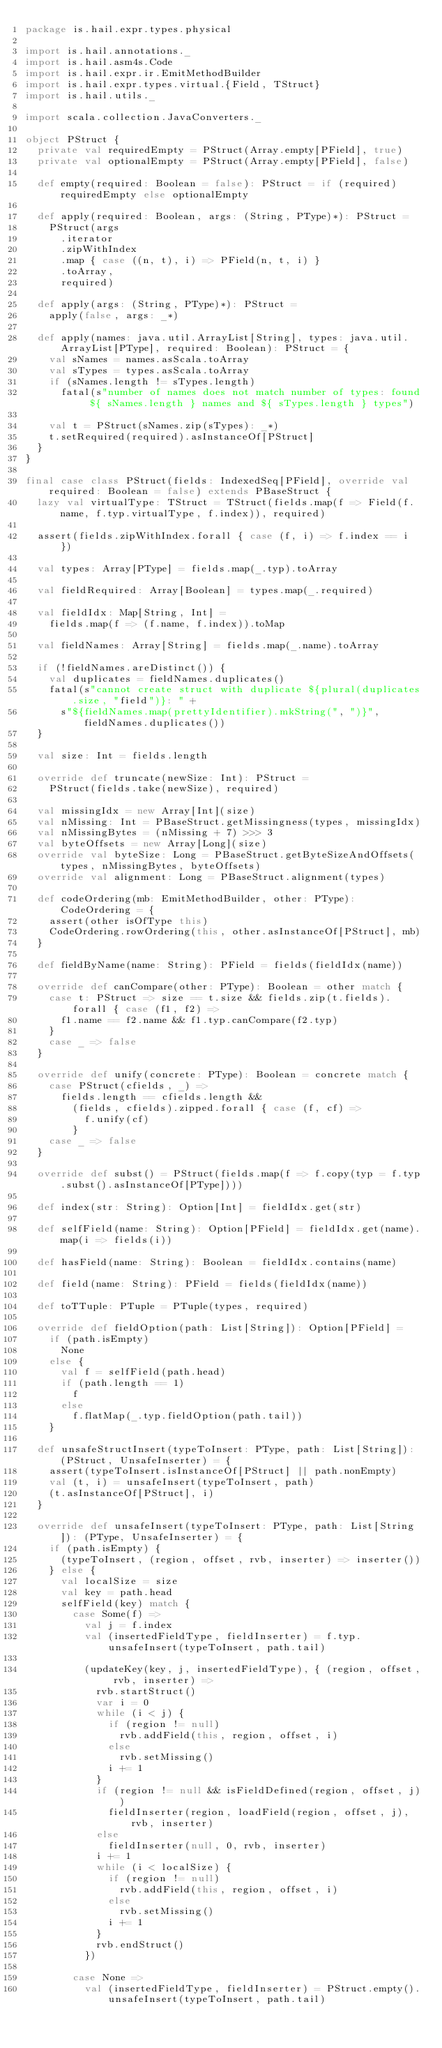<code> <loc_0><loc_0><loc_500><loc_500><_Scala_>package is.hail.expr.types.physical

import is.hail.annotations._
import is.hail.asm4s.Code
import is.hail.expr.ir.EmitMethodBuilder
import is.hail.expr.types.virtual.{Field, TStruct}
import is.hail.utils._

import scala.collection.JavaConverters._

object PStruct {
  private val requiredEmpty = PStruct(Array.empty[PField], true)
  private val optionalEmpty = PStruct(Array.empty[PField], false)

  def empty(required: Boolean = false): PStruct = if (required) requiredEmpty else optionalEmpty

  def apply(required: Boolean, args: (String, PType)*): PStruct =
    PStruct(args
      .iterator
      .zipWithIndex
      .map { case ((n, t), i) => PField(n, t, i) }
      .toArray,
      required)

  def apply(args: (String, PType)*): PStruct =
    apply(false, args: _*)

  def apply(names: java.util.ArrayList[String], types: java.util.ArrayList[PType], required: Boolean): PStruct = {
    val sNames = names.asScala.toArray
    val sTypes = types.asScala.toArray
    if (sNames.length != sTypes.length)
      fatal(s"number of names does not match number of types: found ${ sNames.length } names and ${ sTypes.length } types")

    val t = PStruct(sNames.zip(sTypes): _*)
    t.setRequired(required).asInstanceOf[PStruct]
  }
}

final case class PStruct(fields: IndexedSeq[PField], override val required: Boolean = false) extends PBaseStruct {
  lazy val virtualType: TStruct = TStruct(fields.map(f => Field(f.name, f.typ.virtualType, f.index)), required)

  assert(fields.zipWithIndex.forall { case (f, i) => f.index == i })

  val types: Array[PType] = fields.map(_.typ).toArray

  val fieldRequired: Array[Boolean] = types.map(_.required)

  val fieldIdx: Map[String, Int] =
    fields.map(f => (f.name, f.index)).toMap

  val fieldNames: Array[String] = fields.map(_.name).toArray

  if (!fieldNames.areDistinct()) {
    val duplicates = fieldNames.duplicates()
    fatal(s"cannot create struct with duplicate ${plural(duplicates.size, "field")}: " +
      s"${fieldNames.map(prettyIdentifier).mkString(", ")}", fieldNames.duplicates())
  }

  val size: Int = fields.length

  override def truncate(newSize: Int): PStruct =
    PStruct(fields.take(newSize), required)

  val missingIdx = new Array[Int](size)
  val nMissing: Int = PBaseStruct.getMissingness(types, missingIdx)
  val nMissingBytes = (nMissing + 7) >>> 3
  val byteOffsets = new Array[Long](size)
  override val byteSize: Long = PBaseStruct.getByteSizeAndOffsets(types, nMissingBytes, byteOffsets)
  override val alignment: Long = PBaseStruct.alignment(types)

  def codeOrdering(mb: EmitMethodBuilder, other: PType): CodeOrdering = {
    assert(other isOfType this)
    CodeOrdering.rowOrdering(this, other.asInstanceOf[PStruct], mb)
  }

  def fieldByName(name: String): PField = fields(fieldIdx(name))

  override def canCompare(other: PType): Boolean = other match {
    case t: PStruct => size == t.size && fields.zip(t.fields).forall { case (f1, f2) =>
      f1.name == f2.name && f1.typ.canCompare(f2.typ)
    }
    case _ => false
  }

  override def unify(concrete: PType): Boolean = concrete match {
    case PStruct(cfields, _) =>
      fields.length == cfields.length &&
        (fields, cfields).zipped.forall { case (f, cf) =>
          f.unify(cf)
        }
    case _ => false
  }

  override def subst() = PStruct(fields.map(f => f.copy(typ = f.typ.subst().asInstanceOf[PType])))

  def index(str: String): Option[Int] = fieldIdx.get(str)

  def selfField(name: String): Option[PField] = fieldIdx.get(name).map(i => fields(i))

  def hasField(name: String): Boolean = fieldIdx.contains(name)

  def field(name: String): PField = fields(fieldIdx(name))

  def toTTuple: PTuple = PTuple(types, required)

  override def fieldOption(path: List[String]): Option[PField] =
    if (path.isEmpty)
      None
    else {
      val f = selfField(path.head)
      if (path.length == 1)
        f
      else
        f.flatMap(_.typ.fieldOption(path.tail))
    }

  def unsafeStructInsert(typeToInsert: PType, path: List[String]): (PStruct, UnsafeInserter) = {
    assert(typeToInsert.isInstanceOf[PStruct] || path.nonEmpty)
    val (t, i) = unsafeInsert(typeToInsert, path)
    (t.asInstanceOf[PStruct], i)
  }

  override def unsafeInsert(typeToInsert: PType, path: List[String]): (PType, UnsafeInserter) = {
    if (path.isEmpty) {
      (typeToInsert, (region, offset, rvb, inserter) => inserter())
    } else {
      val localSize = size
      val key = path.head
      selfField(key) match {
        case Some(f) =>
          val j = f.index
          val (insertedFieldType, fieldInserter) = f.typ.unsafeInsert(typeToInsert, path.tail)

          (updateKey(key, j, insertedFieldType), { (region, offset, rvb, inserter) =>
            rvb.startStruct()
            var i = 0
            while (i < j) {
              if (region != null)
                rvb.addField(this, region, offset, i)
              else
                rvb.setMissing()
              i += 1
            }
            if (region != null && isFieldDefined(region, offset, j))
              fieldInserter(region, loadField(region, offset, j), rvb, inserter)
            else
              fieldInserter(null, 0, rvb, inserter)
            i += 1
            while (i < localSize) {
              if (region != null)
                rvb.addField(this, region, offset, i)
              else
                rvb.setMissing()
              i += 1
            }
            rvb.endStruct()
          })

        case None =>
          val (insertedFieldType, fieldInserter) = PStruct.empty().unsafeInsert(typeToInsert, path.tail)
</code> 